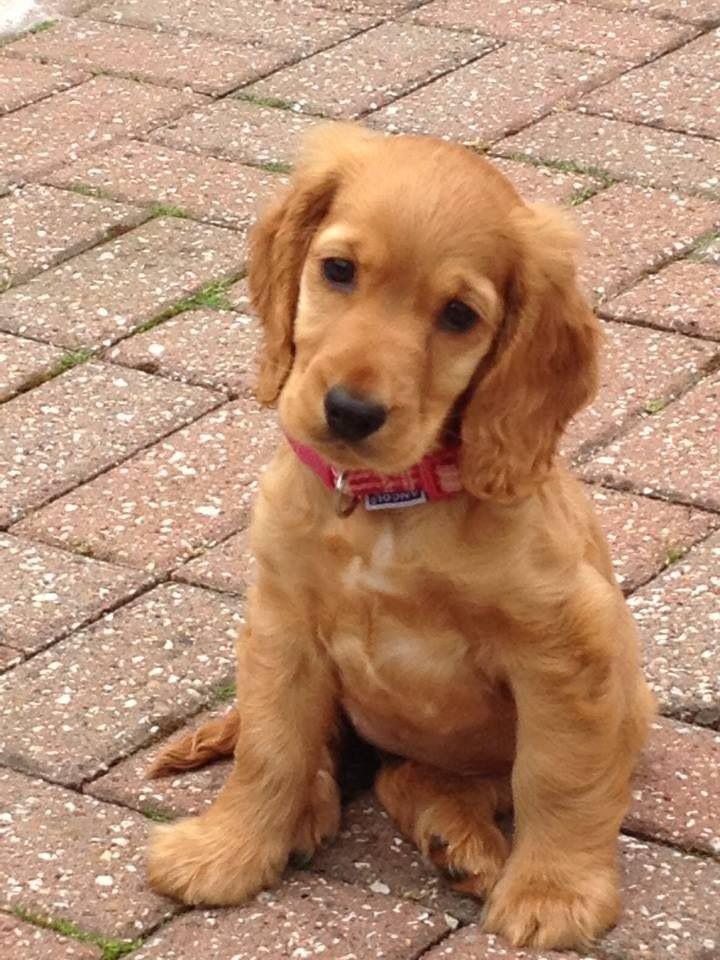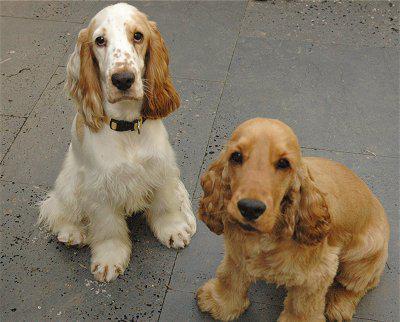The first image is the image on the left, the second image is the image on the right. Considering the images on both sides, is "The dogs in the image on the right are not on grass." valid? Answer yes or no. Yes. 